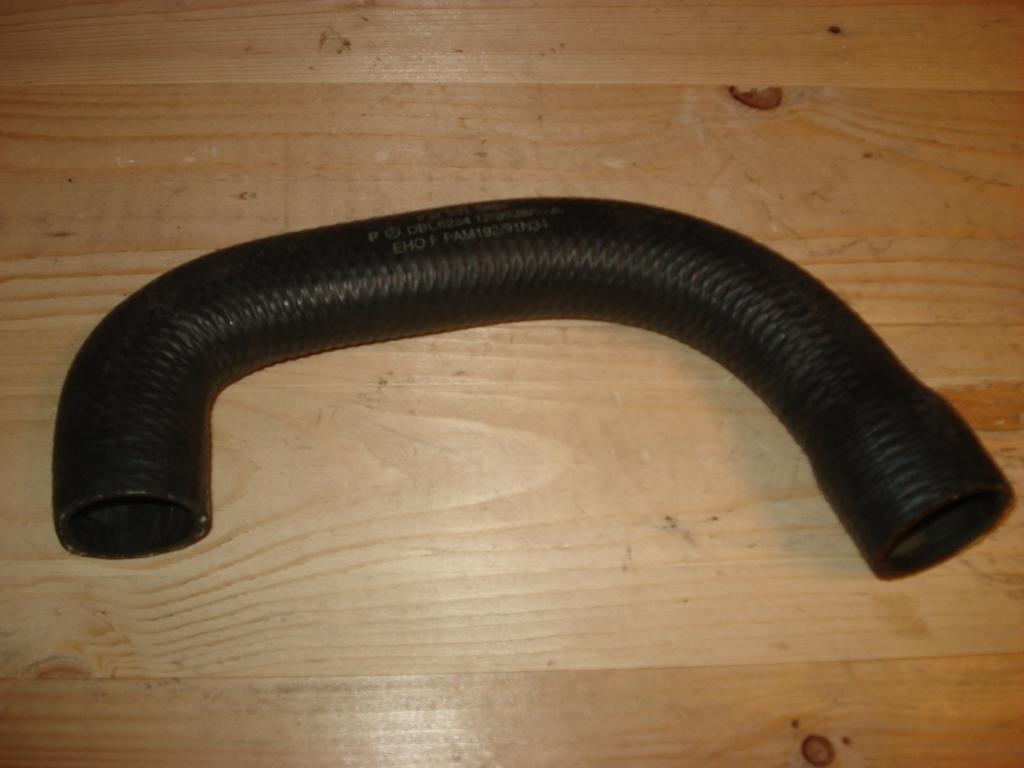What type of surface is visible in the image? There is a wooden surface in the image. What object is placed on the wooden surface? There is a black tube on the wooden surface. Is there any text or markings on the black tube? Yes, there is writing on the black tube. What metal object can be seen acting as a level in the image? There is no metal object acting as a level in the image. The image only features a wooden surface with a black tube on it, and there is no mention of a level or any metal objects. 